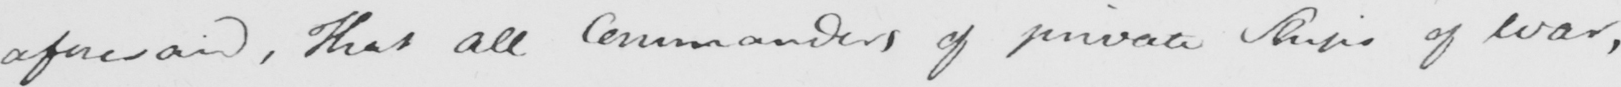Please transcribe the handwritten text in this image. aforesaid , That all Commanders of Private Ships of War , 